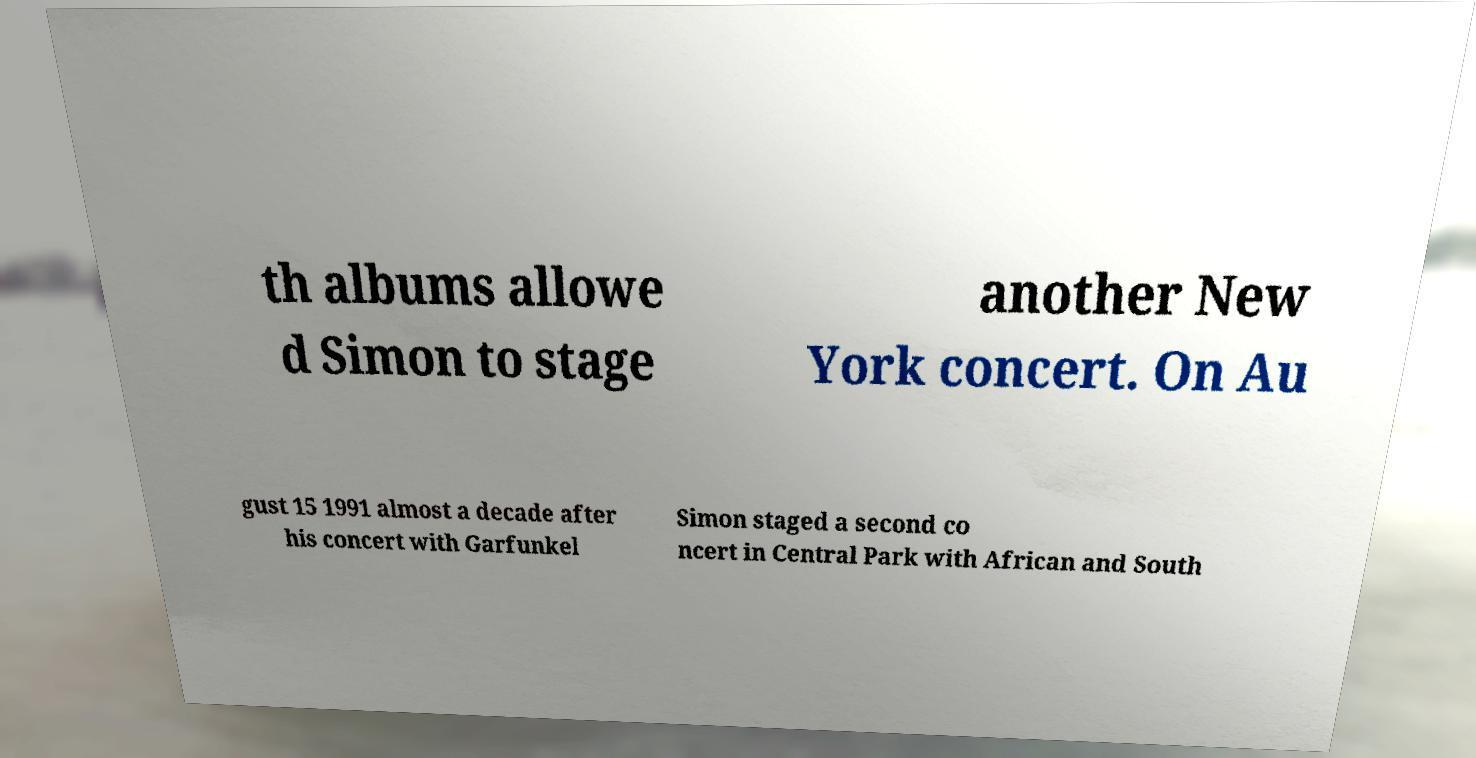Please identify and transcribe the text found in this image. th albums allowe d Simon to stage another New York concert. On Au gust 15 1991 almost a decade after his concert with Garfunkel Simon staged a second co ncert in Central Park with African and South 